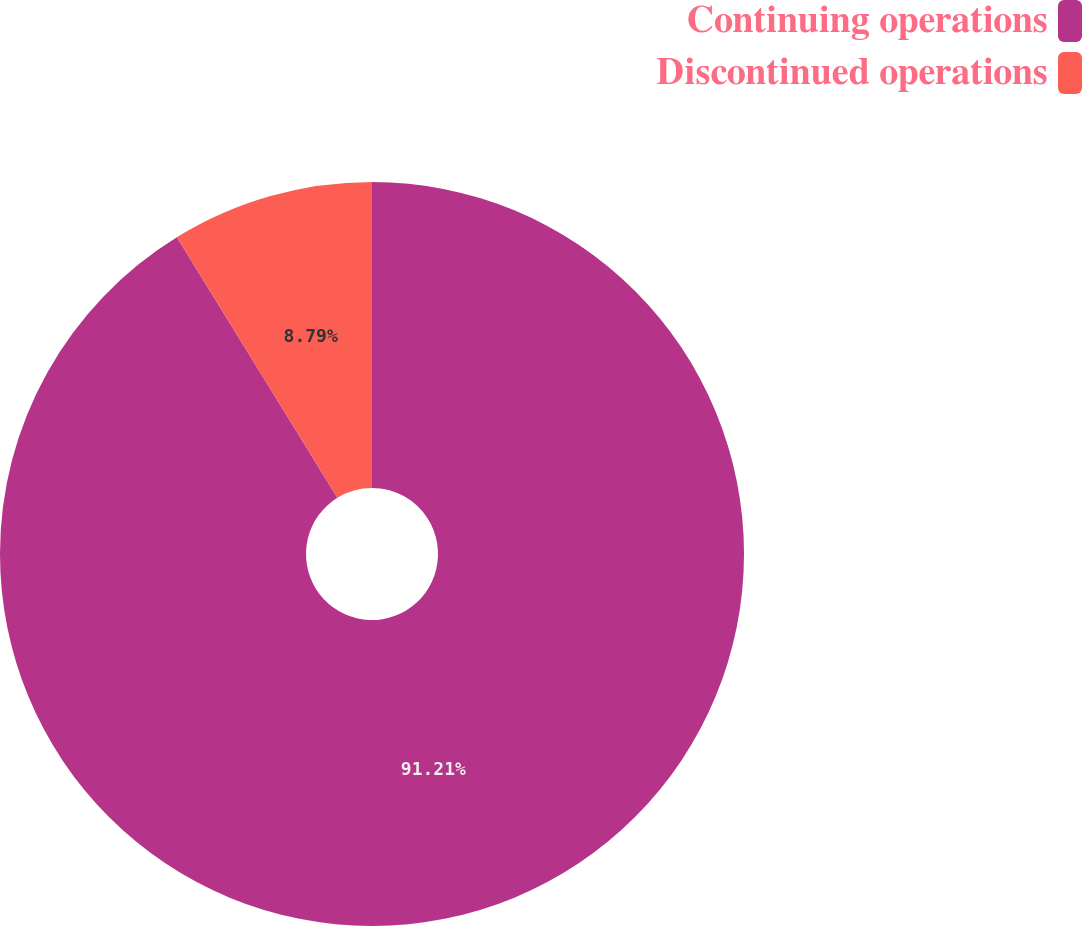Convert chart. <chart><loc_0><loc_0><loc_500><loc_500><pie_chart><fcel>Continuing operations<fcel>Discontinued operations<nl><fcel>91.21%<fcel>8.79%<nl></chart> 